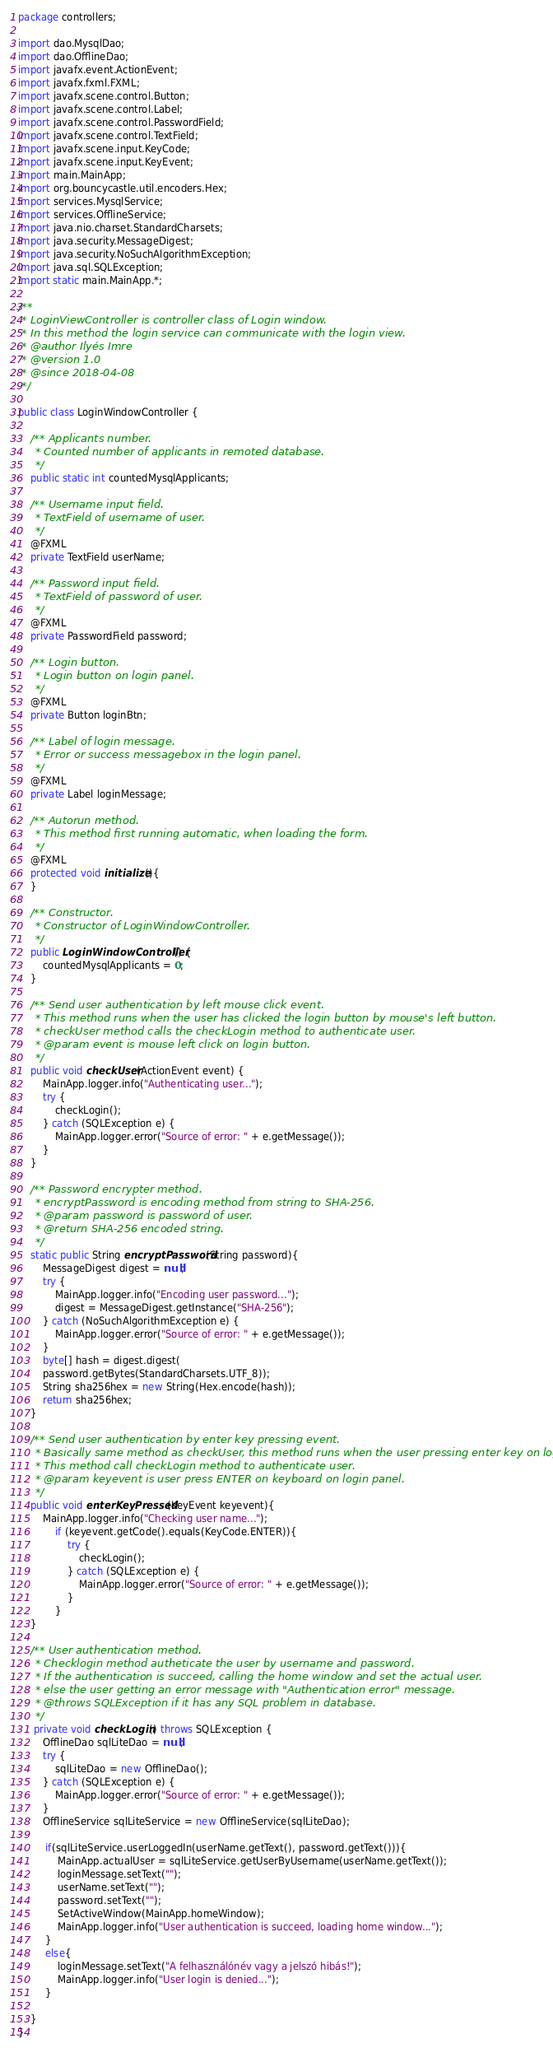<code> <loc_0><loc_0><loc_500><loc_500><_Java_>package controllers;

import dao.MysqlDao;
import dao.OfflineDao;
import javafx.event.ActionEvent;
import javafx.fxml.FXML;
import javafx.scene.control.Button;
import javafx.scene.control.Label;
import javafx.scene.control.PasswordField;
import javafx.scene.control.TextField;
import javafx.scene.input.KeyCode;
import javafx.scene.input.KeyEvent;
import main.MainApp;
import org.bouncycastle.util.encoders.Hex;
import services.MysqlService;
import services.OfflineService;
import java.nio.charset.StandardCharsets;
import java.security.MessageDigest;
import java.security.NoSuchAlgorithmException;
import java.sql.SQLException;
import static main.MainApp.*;

/**
 * LoginViewController is controller class of Login window.
 * In this method the login service can communicate with the login view.
 * @author Ilyés Imre
 * @version 1.0
 * @since 2018-04-08
 */

public class LoginWindowController {

    /** Applicants number.
     * Counted number of applicants in remoted database.
     */
    public static int countedMysqlApplicants;

    /** Username input field.
     * TextField of username of user.
     */
    @FXML
    private TextField userName;

    /** Password input field.
     * TextField of password of user.
     */
    @FXML
    private PasswordField password;

    /** Login button.
     * Login button on login panel.
     */
    @FXML
    private Button loginBtn;

    /** Label of login message.
     * Error or success messagebox in the login panel.
     */
    @FXML
    private Label loginMessage;

    /** Autorun method.
     * This method first running automatic, when loading the form.
     */
    @FXML
    protected void initialize(){
    }

    /** Constructor.
     * Constructor of LoginWindowController.
     */
    public LoginWindowController() {
        countedMysqlApplicants = 0;
    }

    /** Send user authentication by left mouse click event.
     * This method runs when the user has clicked the login button by mouse's left button.
     * checkUser method calls the checkLogin method to authenticate user.
     * @param event is mouse left click on login button.
     */
    public void checkUser(ActionEvent event) {
        MainApp.logger.info("Authenticating user...");
        try {
            checkLogin();
        } catch (SQLException e) {
            MainApp.logger.error("Source of error: " + e.getMessage());
        }
    }

    /** Password encrypter method.
     * encryptPassword is encoding method from string to SHA-256.
     * @param password is password of user.
     * @return SHA-256 encoded string.
     */
    static public String encryptPassword(String password){
        MessageDigest digest = null;
        try {
            MainApp.logger.info("Encoding user password...");
            digest = MessageDigest.getInstance("SHA-256");
        } catch (NoSuchAlgorithmException e) {
            MainApp.logger.error("Source of error: " + e.getMessage());
        }
        byte[] hash = digest.digest(
        password.getBytes(StandardCharsets.UTF_8));
        String sha256hex = new String(Hex.encode(hash));
        return sha256hex;
    }

    /** Send user authentication by enter key pressing event.
     * Basically same method as checkUser, this method runs when the user pressing enter key on login form.
     * This method call checkLogin method to authenticate user.
     * @param keyevent is user press ENTER on keyboard on login panel.
     */
    public void enterKeyPressed(KeyEvent keyevent){
        MainApp.logger.info("Checking user name...");
            if (keyevent.getCode().equals(KeyCode.ENTER)){
                try {
                    checkLogin();
                } catch (SQLException e) {
                    MainApp.logger.error("Source of error: " + e.getMessage());
                }
            }
    }

    /** User authentication method.
     * Checklogin method autheticate the user by username and password.
     * If the authentication is succeed, calling the home window and set the actual user.
     * else the user getting an error message with "Authentication error" message.
     * @throws SQLException if it has any SQL problem in database.
     */
     private void checkLogin() throws SQLException {
        OfflineDao sqlLiteDao = null;
        try {
            sqlLiteDao = new OfflineDao();
        } catch (SQLException e) {
            MainApp.logger.error("Source of error: " + e.getMessage());
        }
        OfflineService sqlLiteService = new OfflineService(sqlLiteDao);

         if(sqlLiteService.userLoggedIn(userName.getText(), password.getText())){
             MainApp.actualUser = sqlLiteService.getUserByUsername(userName.getText());
             loginMessage.setText("");
             userName.setText("");
             password.setText("");
             SetActiveWindow(MainApp.homeWindow);
             MainApp.logger.info("User authentication is succeed, loading home window...");
         }
         else{
             loginMessage.setText("A felhasználónév vagy a jelszó hibás!");
             MainApp.logger.info("User login is denied...");
         }

    }
}
</code> 